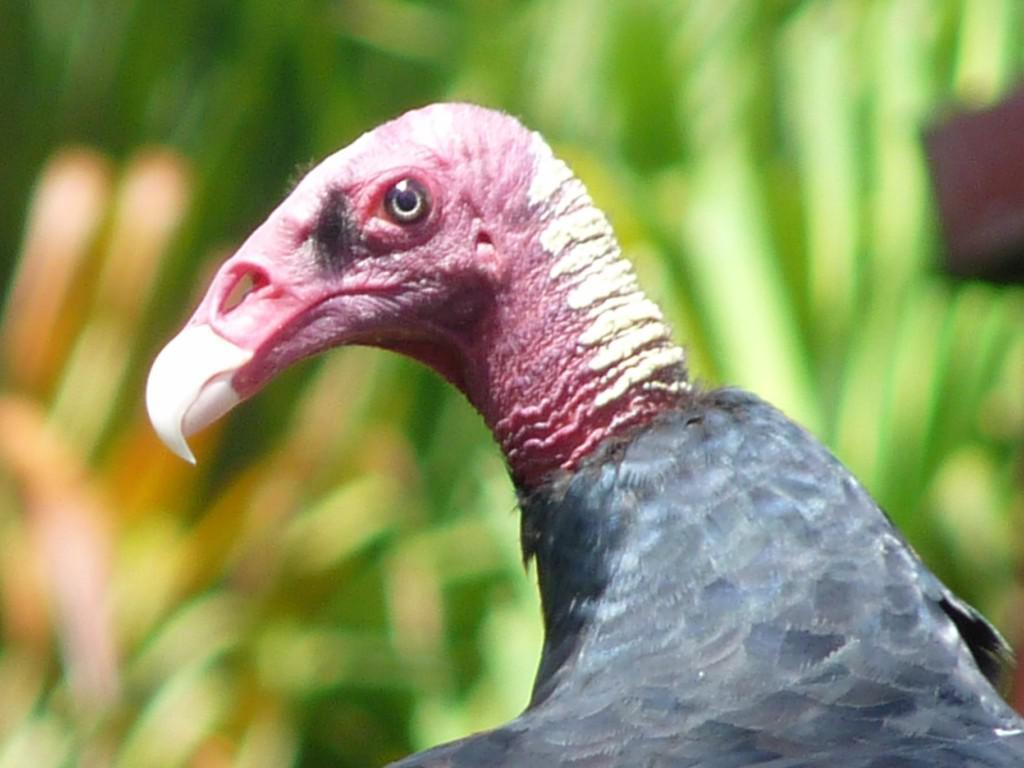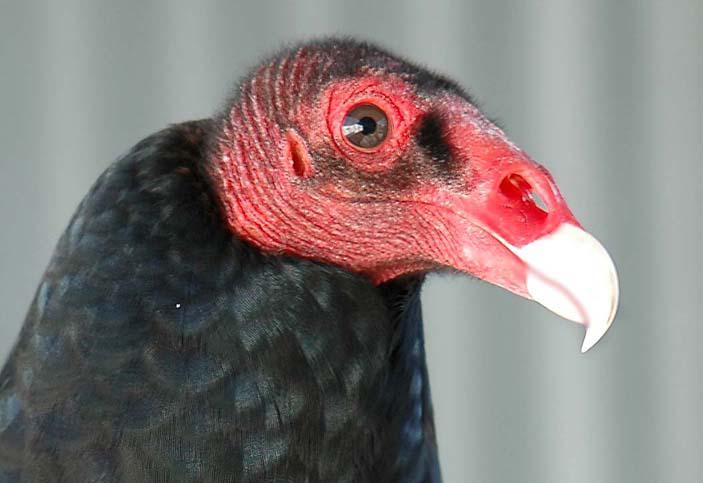The first image is the image on the left, the second image is the image on the right. Analyze the images presented: Is the assertion "An image shows a vulture standing on a kind of perch." valid? Answer yes or no. No. 